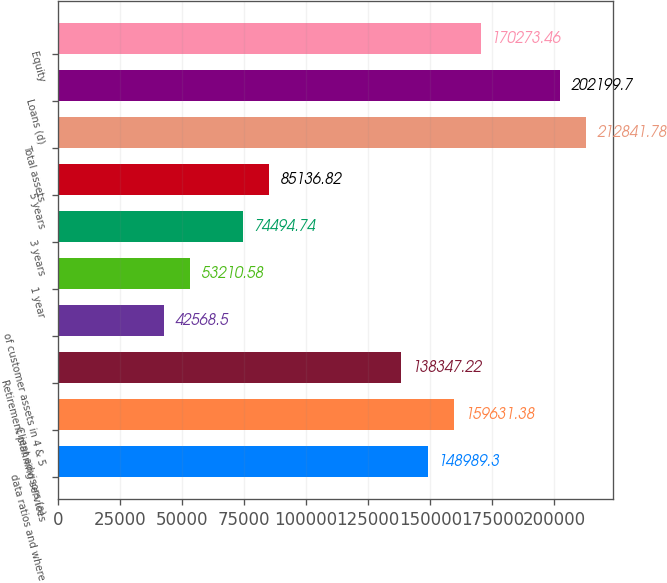Convert chart. <chart><loc_0><loc_0><loc_500><loc_500><bar_chart><fcel>data ratios and where<fcel>Client advisors (a)<fcel>Retirement planning services<fcel>of customer assets in 4 & 5<fcel>1 year<fcel>3 years<fcel>5 years<fcel>Total assets<fcel>Loans (d)<fcel>Equity<nl><fcel>148989<fcel>159631<fcel>138347<fcel>42568.5<fcel>53210.6<fcel>74494.7<fcel>85136.8<fcel>212842<fcel>202200<fcel>170273<nl></chart> 